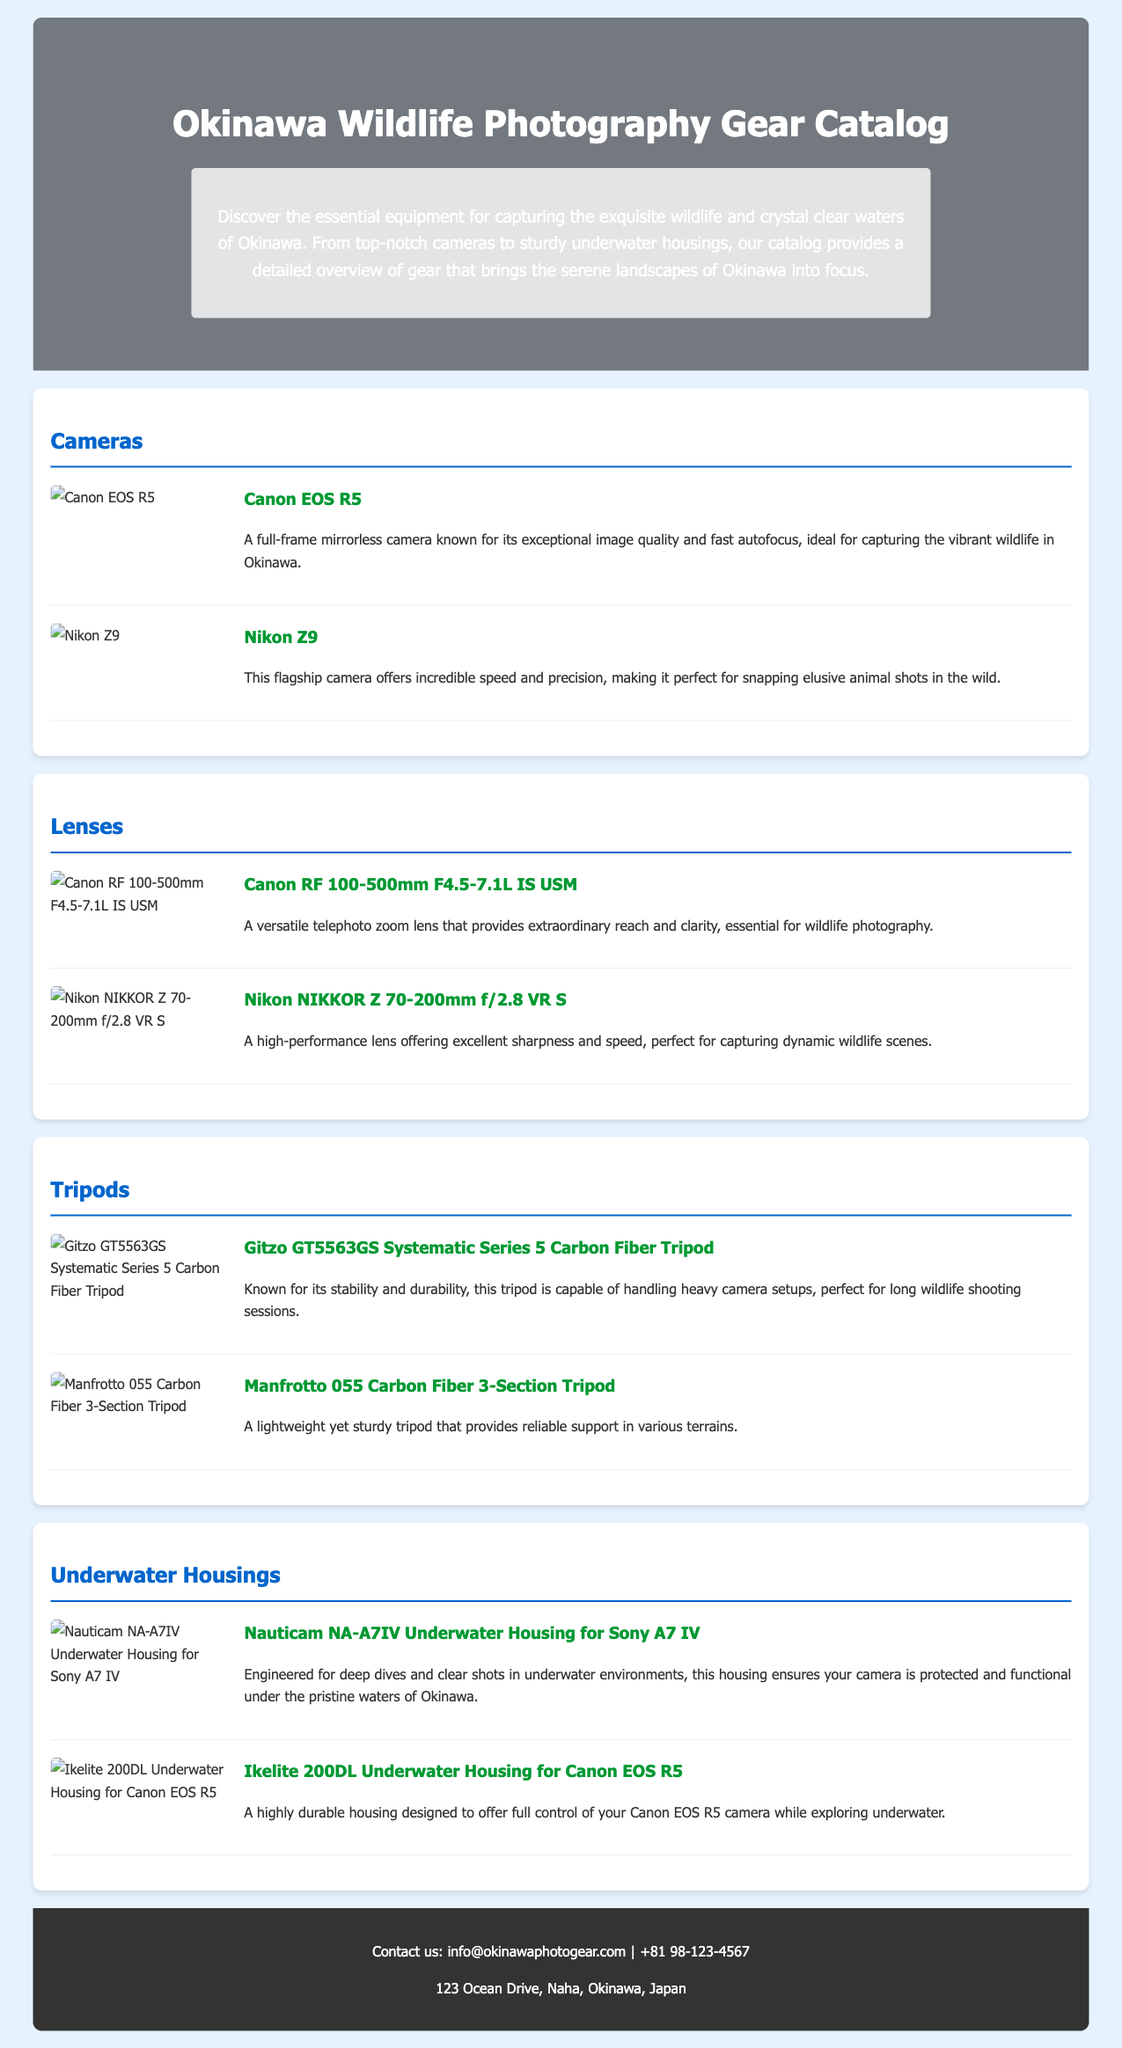what is the title of the catalog? The title of the catalog is stated prominently at the top of the document, indicating the focus on wildlife photography gear.
Answer: Okinawa Wildlife Photography Gear Catalog how many camera models are listed in the catalog? The catalog mentions two camera models under the cameras category, indicating a focus on high-quality options.
Answer: 2 what type of lens is the Canon RF 100-500mm? The catalog provides a description of the lens under the lenses category, highlighting its characteristics for wildlife photography.
Answer: Telephoto zoom lens which tripod is known for its stability and durability? The catalog describes the Gitzo GT5563GS tripod as having high stability and durability, suitable for long shooting sessions.
Answer: Gitzo GT5563GS Systematic Series 5 Carbon Fiber Tripod what is the main purpose of the Nauticam NA-A7IV? The Nauticam NA-A7IV is specified in the catalog as designed for underwater photography, highlighting its protective features.
Answer: Underwater housing which camera brand is featured alongside Canon in the camera section? The Nikon Z9 is mentioned alongside the Canon EOS R5, indicating competition between these brands for wildlife photography.
Answer: Nikon 